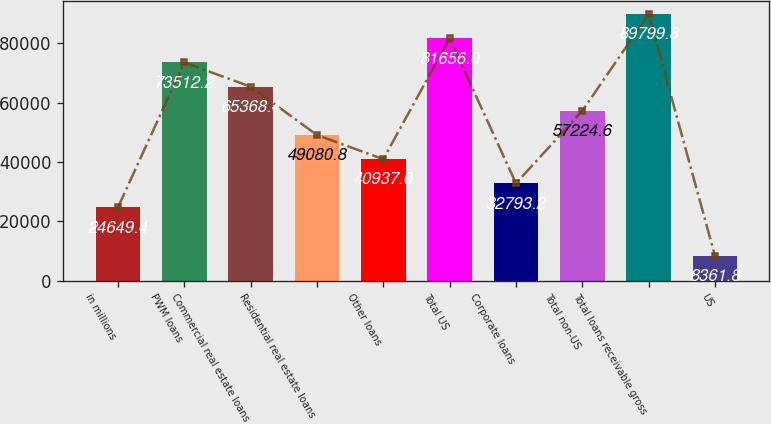Convert chart to OTSL. <chart><loc_0><loc_0><loc_500><loc_500><bar_chart><fcel>in millions<fcel>PWM loans<fcel>Commercial real estate loans<fcel>Residential real estate loans<fcel>Other loans<fcel>Total US<fcel>Corporate loans<fcel>Total non-US<fcel>Total loans receivable gross<fcel>US<nl><fcel>24649.4<fcel>73512.2<fcel>65368.4<fcel>49080.8<fcel>40937<fcel>81656<fcel>32793.2<fcel>57224.6<fcel>89799.8<fcel>8361.8<nl></chart> 